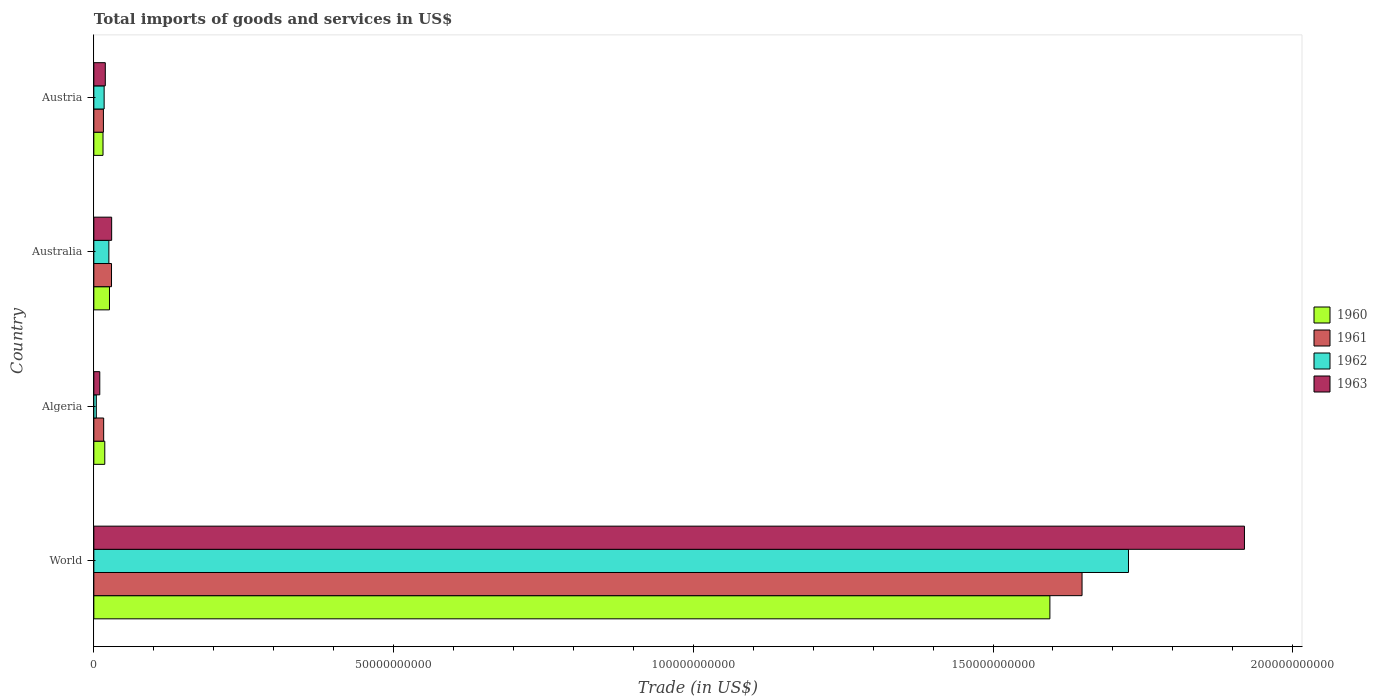How many different coloured bars are there?
Offer a very short reply. 4. Are the number of bars per tick equal to the number of legend labels?
Your answer should be very brief. Yes. How many bars are there on the 2nd tick from the top?
Offer a terse response. 4. How many bars are there on the 2nd tick from the bottom?
Offer a very short reply. 4. In how many cases, is the number of bars for a given country not equal to the number of legend labels?
Give a very brief answer. 0. What is the total imports of goods and services in 1960 in Austria?
Give a very brief answer. 1.53e+09. Across all countries, what is the maximum total imports of goods and services in 1961?
Offer a terse response. 1.65e+11. Across all countries, what is the minimum total imports of goods and services in 1960?
Give a very brief answer. 1.53e+09. In which country was the total imports of goods and services in 1963 minimum?
Offer a terse response. Algeria. What is the total total imports of goods and services in 1963 in the graph?
Your answer should be compact. 1.98e+11. What is the difference between the total imports of goods and services in 1962 in Algeria and that in Australia?
Keep it short and to the point. -2.10e+09. What is the difference between the total imports of goods and services in 1962 in Austria and the total imports of goods and services in 1961 in Algeria?
Your response must be concise. 7.84e+07. What is the average total imports of goods and services in 1962 per country?
Your response must be concise. 4.43e+1. What is the difference between the total imports of goods and services in 1961 and total imports of goods and services in 1960 in Australia?
Your answer should be compact. 3.40e+08. In how many countries, is the total imports of goods and services in 1961 greater than 170000000000 US$?
Keep it short and to the point. 0. What is the ratio of the total imports of goods and services in 1962 in Algeria to that in World?
Your response must be concise. 0. Is the total imports of goods and services in 1961 in Australia less than that in Austria?
Give a very brief answer. No. What is the difference between the highest and the second highest total imports of goods and services in 1960?
Keep it short and to the point. 1.57e+11. What is the difference between the highest and the lowest total imports of goods and services in 1962?
Provide a succinct answer. 1.72e+11. In how many countries, is the total imports of goods and services in 1961 greater than the average total imports of goods and services in 1961 taken over all countries?
Give a very brief answer. 1. Is it the case that in every country, the sum of the total imports of goods and services in 1962 and total imports of goods and services in 1960 is greater than the sum of total imports of goods and services in 1961 and total imports of goods and services in 1963?
Your response must be concise. No. What does the 3rd bar from the top in Algeria represents?
Keep it short and to the point. 1961. Is it the case that in every country, the sum of the total imports of goods and services in 1961 and total imports of goods and services in 1962 is greater than the total imports of goods and services in 1960?
Give a very brief answer. Yes. How many bars are there?
Your response must be concise. 16. Are all the bars in the graph horizontal?
Give a very brief answer. Yes. What is the difference between two consecutive major ticks on the X-axis?
Your answer should be very brief. 5.00e+1. Does the graph contain any zero values?
Keep it short and to the point. No. Does the graph contain grids?
Make the answer very short. No. How many legend labels are there?
Your answer should be compact. 4. What is the title of the graph?
Keep it short and to the point. Total imports of goods and services in US$. Does "1994" appear as one of the legend labels in the graph?
Keep it short and to the point. No. What is the label or title of the X-axis?
Provide a succinct answer. Trade (in US$). What is the label or title of the Y-axis?
Give a very brief answer. Country. What is the Trade (in US$) in 1960 in World?
Ensure brevity in your answer.  1.59e+11. What is the Trade (in US$) of 1961 in World?
Give a very brief answer. 1.65e+11. What is the Trade (in US$) of 1962 in World?
Make the answer very short. 1.73e+11. What is the Trade (in US$) in 1963 in World?
Your answer should be very brief. 1.92e+11. What is the Trade (in US$) of 1960 in Algeria?
Give a very brief answer. 1.83e+09. What is the Trade (in US$) of 1961 in Algeria?
Give a very brief answer. 1.64e+09. What is the Trade (in US$) of 1962 in Algeria?
Your answer should be compact. 4.17e+08. What is the Trade (in US$) in 1963 in Algeria?
Your answer should be very brief. 9.95e+08. What is the Trade (in US$) in 1960 in Australia?
Your response must be concise. 2.61e+09. What is the Trade (in US$) of 1961 in Australia?
Your response must be concise. 2.95e+09. What is the Trade (in US$) in 1962 in Australia?
Your answer should be very brief. 2.51e+09. What is the Trade (in US$) in 1963 in Australia?
Give a very brief answer. 2.97e+09. What is the Trade (in US$) in 1960 in Austria?
Make the answer very short. 1.53e+09. What is the Trade (in US$) in 1961 in Austria?
Provide a short and direct response. 1.60e+09. What is the Trade (in US$) of 1962 in Austria?
Your answer should be compact. 1.72e+09. What is the Trade (in US$) in 1963 in Austria?
Provide a short and direct response. 1.91e+09. Across all countries, what is the maximum Trade (in US$) in 1960?
Keep it short and to the point. 1.59e+11. Across all countries, what is the maximum Trade (in US$) of 1961?
Make the answer very short. 1.65e+11. Across all countries, what is the maximum Trade (in US$) of 1962?
Give a very brief answer. 1.73e+11. Across all countries, what is the maximum Trade (in US$) in 1963?
Ensure brevity in your answer.  1.92e+11. Across all countries, what is the minimum Trade (in US$) in 1960?
Give a very brief answer. 1.53e+09. Across all countries, what is the minimum Trade (in US$) in 1961?
Your answer should be very brief. 1.60e+09. Across all countries, what is the minimum Trade (in US$) of 1962?
Your answer should be compact. 4.17e+08. Across all countries, what is the minimum Trade (in US$) of 1963?
Your answer should be compact. 9.95e+08. What is the total Trade (in US$) in 1960 in the graph?
Your answer should be compact. 1.65e+11. What is the total Trade (in US$) of 1961 in the graph?
Offer a terse response. 1.71e+11. What is the total Trade (in US$) in 1962 in the graph?
Your response must be concise. 1.77e+11. What is the total Trade (in US$) in 1963 in the graph?
Offer a very short reply. 1.98e+11. What is the difference between the Trade (in US$) in 1960 in World and that in Algeria?
Offer a terse response. 1.58e+11. What is the difference between the Trade (in US$) of 1961 in World and that in Algeria?
Your answer should be compact. 1.63e+11. What is the difference between the Trade (in US$) of 1962 in World and that in Algeria?
Offer a very short reply. 1.72e+11. What is the difference between the Trade (in US$) of 1963 in World and that in Algeria?
Make the answer very short. 1.91e+11. What is the difference between the Trade (in US$) in 1960 in World and that in Australia?
Your response must be concise. 1.57e+11. What is the difference between the Trade (in US$) in 1961 in World and that in Australia?
Provide a succinct answer. 1.62e+11. What is the difference between the Trade (in US$) of 1962 in World and that in Australia?
Your response must be concise. 1.70e+11. What is the difference between the Trade (in US$) in 1963 in World and that in Australia?
Keep it short and to the point. 1.89e+11. What is the difference between the Trade (in US$) of 1960 in World and that in Austria?
Your answer should be very brief. 1.58e+11. What is the difference between the Trade (in US$) in 1961 in World and that in Austria?
Offer a very short reply. 1.63e+11. What is the difference between the Trade (in US$) in 1962 in World and that in Austria?
Make the answer very short. 1.71e+11. What is the difference between the Trade (in US$) in 1963 in World and that in Austria?
Give a very brief answer. 1.90e+11. What is the difference between the Trade (in US$) of 1960 in Algeria and that in Australia?
Keep it short and to the point. -7.83e+08. What is the difference between the Trade (in US$) of 1961 in Algeria and that in Australia?
Keep it short and to the point. -1.31e+09. What is the difference between the Trade (in US$) of 1962 in Algeria and that in Australia?
Offer a terse response. -2.10e+09. What is the difference between the Trade (in US$) in 1963 in Algeria and that in Australia?
Make the answer very short. -1.98e+09. What is the difference between the Trade (in US$) of 1960 in Algeria and that in Austria?
Keep it short and to the point. 2.95e+08. What is the difference between the Trade (in US$) of 1961 in Algeria and that in Austria?
Offer a terse response. 4.21e+07. What is the difference between the Trade (in US$) of 1962 in Algeria and that in Austria?
Your answer should be compact. -1.31e+09. What is the difference between the Trade (in US$) of 1963 in Algeria and that in Austria?
Keep it short and to the point. -9.19e+08. What is the difference between the Trade (in US$) of 1960 in Australia and that in Austria?
Your answer should be compact. 1.08e+09. What is the difference between the Trade (in US$) of 1961 in Australia and that in Austria?
Provide a short and direct response. 1.35e+09. What is the difference between the Trade (in US$) in 1962 in Australia and that in Austria?
Provide a succinct answer. 7.90e+08. What is the difference between the Trade (in US$) of 1963 in Australia and that in Austria?
Ensure brevity in your answer.  1.06e+09. What is the difference between the Trade (in US$) in 1960 in World and the Trade (in US$) in 1961 in Algeria?
Your answer should be very brief. 1.58e+11. What is the difference between the Trade (in US$) of 1960 in World and the Trade (in US$) of 1962 in Algeria?
Make the answer very short. 1.59e+11. What is the difference between the Trade (in US$) of 1960 in World and the Trade (in US$) of 1963 in Algeria?
Offer a very short reply. 1.58e+11. What is the difference between the Trade (in US$) of 1961 in World and the Trade (in US$) of 1962 in Algeria?
Keep it short and to the point. 1.64e+11. What is the difference between the Trade (in US$) of 1961 in World and the Trade (in US$) of 1963 in Algeria?
Provide a succinct answer. 1.64e+11. What is the difference between the Trade (in US$) in 1962 in World and the Trade (in US$) in 1963 in Algeria?
Provide a short and direct response. 1.72e+11. What is the difference between the Trade (in US$) in 1960 in World and the Trade (in US$) in 1961 in Australia?
Offer a terse response. 1.57e+11. What is the difference between the Trade (in US$) in 1960 in World and the Trade (in US$) in 1962 in Australia?
Give a very brief answer. 1.57e+11. What is the difference between the Trade (in US$) of 1960 in World and the Trade (in US$) of 1963 in Australia?
Your answer should be compact. 1.57e+11. What is the difference between the Trade (in US$) in 1961 in World and the Trade (in US$) in 1962 in Australia?
Provide a succinct answer. 1.62e+11. What is the difference between the Trade (in US$) of 1961 in World and the Trade (in US$) of 1963 in Australia?
Make the answer very short. 1.62e+11. What is the difference between the Trade (in US$) of 1962 in World and the Trade (in US$) of 1963 in Australia?
Make the answer very short. 1.70e+11. What is the difference between the Trade (in US$) in 1960 in World and the Trade (in US$) in 1961 in Austria?
Offer a very short reply. 1.58e+11. What is the difference between the Trade (in US$) in 1960 in World and the Trade (in US$) in 1962 in Austria?
Give a very brief answer. 1.58e+11. What is the difference between the Trade (in US$) of 1960 in World and the Trade (in US$) of 1963 in Austria?
Keep it short and to the point. 1.58e+11. What is the difference between the Trade (in US$) of 1961 in World and the Trade (in US$) of 1962 in Austria?
Your answer should be compact. 1.63e+11. What is the difference between the Trade (in US$) in 1961 in World and the Trade (in US$) in 1963 in Austria?
Provide a succinct answer. 1.63e+11. What is the difference between the Trade (in US$) in 1962 in World and the Trade (in US$) in 1963 in Austria?
Your answer should be very brief. 1.71e+11. What is the difference between the Trade (in US$) in 1960 in Algeria and the Trade (in US$) in 1961 in Australia?
Make the answer very short. -1.12e+09. What is the difference between the Trade (in US$) of 1960 in Algeria and the Trade (in US$) of 1962 in Australia?
Your answer should be compact. -6.83e+08. What is the difference between the Trade (in US$) in 1960 in Algeria and the Trade (in US$) in 1963 in Australia?
Your answer should be very brief. -1.15e+09. What is the difference between the Trade (in US$) of 1961 in Algeria and the Trade (in US$) of 1962 in Australia?
Provide a succinct answer. -8.68e+08. What is the difference between the Trade (in US$) of 1961 in Algeria and the Trade (in US$) of 1963 in Australia?
Keep it short and to the point. -1.33e+09. What is the difference between the Trade (in US$) in 1962 in Algeria and the Trade (in US$) in 1963 in Australia?
Your response must be concise. -2.56e+09. What is the difference between the Trade (in US$) in 1960 in Algeria and the Trade (in US$) in 1961 in Austria?
Provide a short and direct response. 2.27e+08. What is the difference between the Trade (in US$) of 1960 in Algeria and the Trade (in US$) of 1962 in Austria?
Make the answer very short. 1.07e+08. What is the difference between the Trade (in US$) of 1960 in Algeria and the Trade (in US$) of 1963 in Austria?
Your answer should be very brief. -8.54e+07. What is the difference between the Trade (in US$) in 1961 in Algeria and the Trade (in US$) in 1962 in Austria?
Provide a succinct answer. -7.84e+07. What is the difference between the Trade (in US$) in 1961 in Algeria and the Trade (in US$) in 1963 in Austria?
Provide a succinct answer. -2.71e+08. What is the difference between the Trade (in US$) of 1962 in Algeria and the Trade (in US$) of 1963 in Austria?
Give a very brief answer. -1.50e+09. What is the difference between the Trade (in US$) in 1960 in Australia and the Trade (in US$) in 1961 in Austria?
Ensure brevity in your answer.  1.01e+09. What is the difference between the Trade (in US$) in 1960 in Australia and the Trade (in US$) in 1962 in Austria?
Provide a short and direct response. 8.90e+08. What is the difference between the Trade (in US$) of 1960 in Australia and the Trade (in US$) of 1963 in Austria?
Your answer should be very brief. 6.98e+08. What is the difference between the Trade (in US$) in 1961 in Australia and the Trade (in US$) in 1962 in Austria?
Offer a terse response. 1.23e+09. What is the difference between the Trade (in US$) in 1961 in Australia and the Trade (in US$) in 1963 in Austria?
Give a very brief answer. 1.04e+09. What is the difference between the Trade (in US$) in 1962 in Australia and the Trade (in US$) in 1963 in Austria?
Ensure brevity in your answer.  5.98e+08. What is the average Trade (in US$) in 1960 per country?
Your answer should be compact. 4.14e+1. What is the average Trade (in US$) of 1961 per country?
Keep it short and to the point. 4.28e+1. What is the average Trade (in US$) of 1962 per country?
Make the answer very short. 4.43e+1. What is the average Trade (in US$) in 1963 per country?
Keep it short and to the point. 4.95e+1. What is the difference between the Trade (in US$) in 1960 and Trade (in US$) in 1961 in World?
Offer a terse response. -5.36e+09. What is the difference between the Trade (in US$) in 1960 and Trade (in US$) in 1962 in World?
Your answer should be compact. -1.31e+1. What is the difference between the Trade (in US$) of 1960 and Trade (in US$) of 1963 in World?
Your response must be concise. -3.25e+1. What is the difference between the Trade (in US$) in 1961 and Trade (in US$) in 1962 in World?
Keep it short and to the point. -7.75e+09. What is the difference between the Trade (in US$) in 1961 and Trade (in US$) in 1963 in World?
Provide a succinct answer. -2.71e+1. What is the difference between the Trade (in US$) of 1962 and Trade (in US$) of 1963 in World?
Keep it short and to the point. -1.93e+1. What is the difference between the Trade (in US$) in 1960 and Trade (in US$) in 1961 in Algeria?
Give a very brief answer. 1.85e+08. What is the difference between the Trade (in US$) of 1960 and Trade (in US$) of 1962 in Algeria?
Keep it short and to the point. 1.41e+09. What is the difference between the Trade (in US$) of 1960 and Trade (in US$) of 1963 in Algeria?
Make the answer very short. 8.33e+08. What is the difference between the Trade (in US$) in 1961 and Trade (in US$) in 1962 in Algeria?
Offer a very short reply. 1.23e+09. What is the difference between the Trade (in US$) in 1961 and Trade (in US$) in 1963 in Algeria?
Provide a succinct answer. 6.48e+08. What is the difference between the Trade (in US$) in 1962 and Trade (in US$) in 1963 in Algeria?
Ensure brevity in your answer.  -5.79e+08. What is the difference between the Trade (in US$) of 1960 and Trade (in US$) of 1961 in Australia?
Your response must be concise. -3.40e+08. What is the difference between the Trade (in US$) of 1960 and Trade (in US$) of 1962 in Australia?
Your response must be concise. 9.97e+07. What is the difference between the Trade (in US$) in 1960 and Trade (in US$) in 1963 in Australia?
Offer a terse response. -3.63e+08. What is the difference between the Trade (in US$) in 1961 and Trade (in US$) in 1962 in Australia?
Your answer should be compact. 4.40e+08. What is the difference between the Trade (in US$) of 1961 and Trade (in US$) of 1963 in Australia?
Offer a very short reply. -2.24e+07. What is the difference between the Trade (in US$) in 1962 and Trade (in US$) in 1963 in Australia?
Your answer should be compact. -4.63e+08. What is the difference between the Trade (in US$) of 1960 and Trade (in US$) of 1961 in Austria?
Your answer should be compact. -6.78e+07. What is the difference between the Trade (in US$) of 1960 and Trade (in US$) of 1962 in Austria?
Offer a very short reply. -1.88e+08. What is the difference between the Trade (in US$) in 1960 and Trade (in US$) in 1963 in Austria?
Make the answer very short. -3.81e+08. What is the difference between the Trade (in US$) in 1961 and Trade (in US$) in 1962 in Austria?
Ensure brevity in your answer.  -1.21e+08. What is the difference between the Trade (in US$) of 1961 and Trade (in US$) of 1963 in Austria?
Your answer should be compact. -3.13e+08. What is the difference between the Trade (in US$) in 1962 and Trade (in US$) in 1963 in Austria?
Ensure brevity in your answer.  -1.92e+08. What is the ratio of the Trade (in US$) in 1960 in World to that in Algeria?
Make the answer very short. 87.21. What is the ratio of the Trade (in US$) in 1961 in World to that in Algeria?
Offer a terse response. 100.3. What is the ratio of the Trade (in US$) in 1962 in World to that in Algeria?
Your response must be concise. 414.23. What is the ratio of the Trade (in US$) in 1963 in World to that in Algeria?
Your answer should be very brief. 192.84. What is the ratio of the Trade (in US$) of 1960 in World to that in Australia?
Provide a short and direct response. 61.07. What is the ratio of the Trade (in US$) of 1961 in World to that in Australia?
Make the answer very short. 55.84. What is the ratio of the Trade (in US$) of 1962 in World to that in Australia?
Make the answer very short. 68.71. What is the ratio of the Trade (in US$) in 1963 in World to that in Australia?
Provide a short and direct response. 64.53. What is the ratio of the Trade (in US$) in 1960 in World to that in Austria?
Your response must be concise. 104. What is the ratio of the Trade (in US$) in 1961 in World to that in Austria?
Ensure brevity in your answer.  102.94. What is the ratio of the Trade (in US$) of 1962 in World to that in Austria?
Provide a short and direct response. 100.23. What is the ratio of the Trade (in US$) of 1963 in World to that in Austria?
Give a very brief answer. 100.28. What is the ratio of the Trade (in US$) in 1960 in Algeria to that in Australia?
Keep it short and to the point. 0.7. What is the ratio of the Trade (in US$) of 1961 in Algeria to that in Australia?
Offer a very short reply. 0.56. What is the ratio of the Trade (in US$) in 1962 in Algeria to that in Australia?
Ensure brevity in your answer.  0.17. What is the ratio of the Trade (in US$) in 1963 in Algeria to that in Australia?
Provide a short and direct response. 0.33. What is the ratio of the Trade (in US$) of 1960 in Algeria to that in Austria?
Provide a succinct answer. 1.19. What is the ratio of the Trade (in US$) of 1961 in Algeria to that in Austria?
Provide a succinct answer. 1.03. What is the ratio of the Trade (in US$) of 1962 in Algeria to that in Austria?
Make the answer very short. 0.24. What is the ratio of the Trade (in US$) of 1963 in Algeria to that in Austria?
Your response must be concise. 0.52. What is the ratio of the Trade (in US$) in 1960 in Australia to that in Austria?
Your response must be concise. 1.7. What is the ratio of the Trade (in US$) in 1961 in Australia to that in Austria?
Your answer should be very brief. 1.84. What is the ratio of the Trade (in US$) in 1962 in Australia to that in Austria?
Your answer should be very brief. 1.46. What is the ratio of the Trade (in US$) of 1963 in Australia to that in Austria?
Your response must be concise. 1.55. What is the difference between the highest and the second highest Trade (in US$) in 1960?
Provide a succinct answer. 1.57e+11. What is the difference between the highest and the second highest Trade (in US$) of 1961?
Keep it short and to the point. 1.62e+11. What is the difference between the highest and the second highest Trade (in US$) in 1962?
Offer a very short reply. 1.70e+11. What is the difference between the highest and the second highest Trade (in US$) of 1963?
Your answer should be compact. 1.89e+11. What is the difference between the highest and the lowest Trade (in US$) of 1960?
Your answer should be very brief. 1.58e+11. What is the difference between the highest and the lowest Trade (in US$) of 1961?
Provide a succinct answer. 1.63e+11. What is the difference between the highest and the lowest Trade (in US$) of 1962?
Provide a short and direct response. 1.72e+11. What is the difference between the highest and the lowest Trade (in US$) of 1963?
Offer a very short reply. 1.91e+11. 